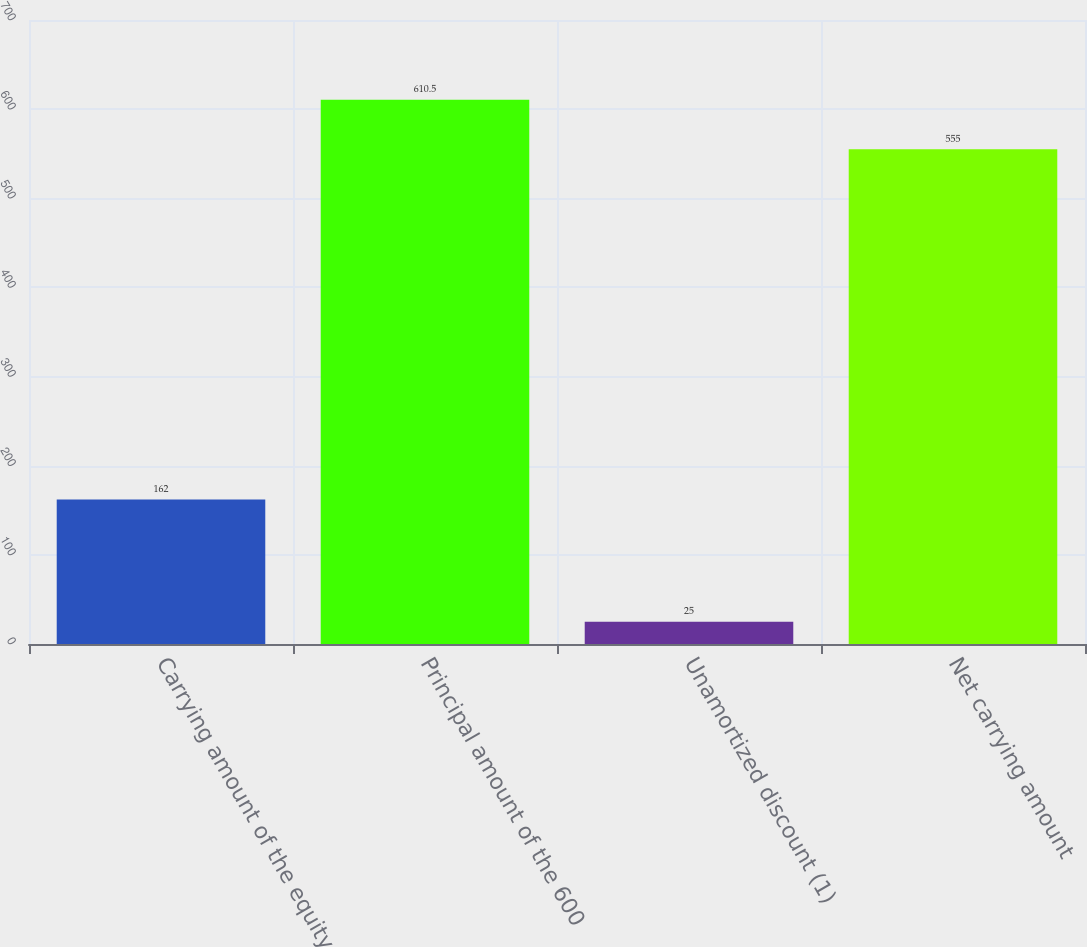<chart> <loc_0><loc_0><loc_500><loc_500><bar_chart><fcel>Carrying amount of the equity<fcel>Principal amount of the 600<fcel>Unamortized discount (1)<fcel>Net carrying amount<nl><fcel>162<fcel>610.5<fcel>25<fcel>555<nl></chart> 